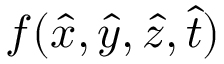Convert formula to latex. <formula><loc_0><loc_0><loc_500><loc_500>f ( \hat { x } , \hat { y } , \hat { z } , \hat { t } )</formula> 